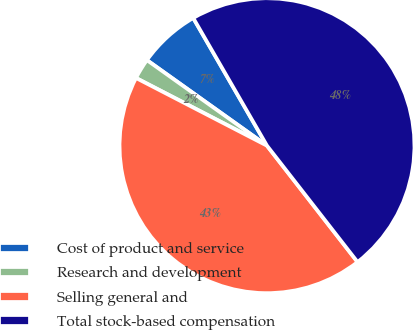Convert chart to OTSL. <chart><loc_0><loc_0><loc_500><loc_500><pie_chart><fcel>Cost of product and service<fcel>Research and development<fcel>Selling general and<fcel>Total stock-based compensation<nl><fcel>6.81%<fcel>2.26%<fcel>43.12%<fcel>47.81%<nl></chart> 